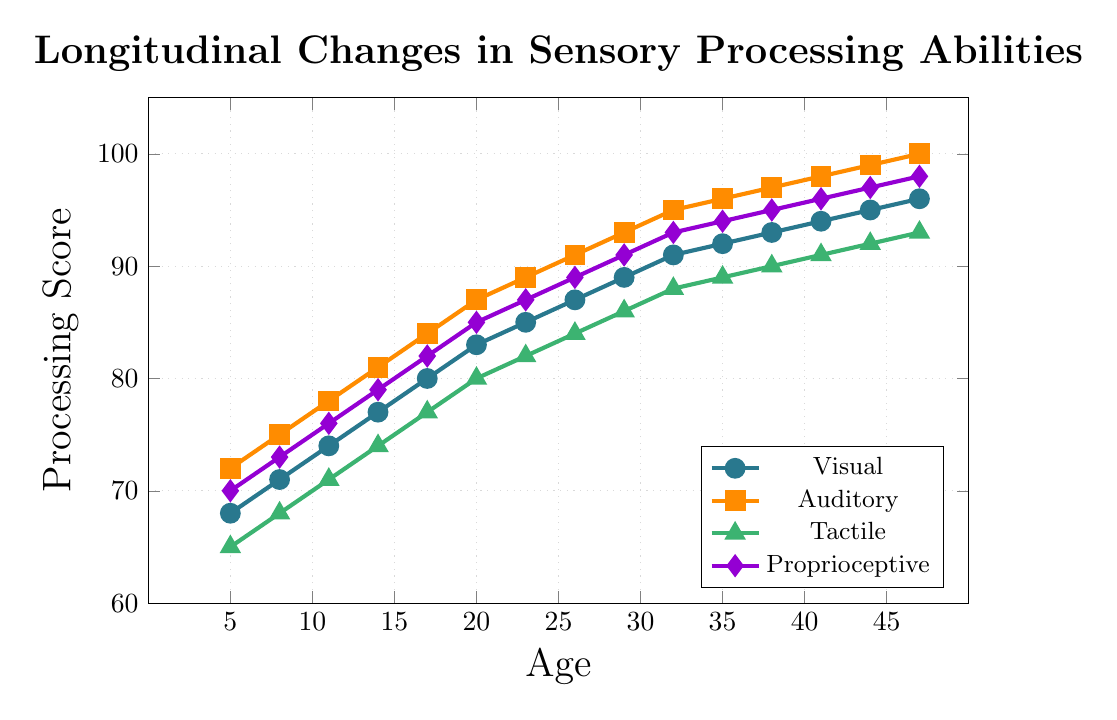What is the overall trend in the Visual Processing Score from age 5 to 47? The Visual Processing Score shows a consistent upward trend from age 5 to 47. This can be seen by the steady increase of the line representing Visual Processing in the chart.
Answer: Upward Trend Which sensory processing ability has the highest score at age 20? At age 20, Auditory Processing has the highest score among all sensory processing abilities. This can be observed by comparing the heights of the lines at the 20-year mark, where the Auditory line reaches the highest position.
Answer: Auditory Processing How many points did the Proprioceptive Processing Score increase from age 5 to age 20? To find the increase, subtract the Proprioceptive Processing Score at age 5 from the score at age 20. The Proprioceptive score at age 5 is 70 and at age 20 is 85. So, 85 - 70 = 15.
Answer: 15 Compare the growth rate of Tactile Processing and Auditory Processing between ages 5 and 17. Which one grew faster? Calculate the differences for both scores between ages 5 and 17. For Tactile Processing: 77 - 65 = 12. For Auditory Processing: 84 - 72 = 12. Both have the same increase, so they grew at the same rate during this period.
Answer: Same rate What is the average Visual Processing Score from age 5 to age 17? Add the Visual Processing Scores at ages 5, 8, 11, 14, and 17, and then divide by the number of data points. (68 + 71 + 74 + 77 + 80) / 5 = 370 / 5
Answer: 74 Between ages 11 and 23, which score increased the least? Calculate the difference for each score between ages 11 and 23. Visual: 85 - 74 = 11, Auditory: 89 - 78 = 11, Tactile: 82 - 71 = 11, Proprioceptive: 87 - 76 = 11. All scores increased by the same amount, so none increased the least.
Answer: None, all the same What is the final difference in the Tactile Processing Score from age 38 to age 47? Subtract the Tactile Processing Score at age 38 from the score at age 47. The Tactile score at age 38 is 90 and at age 47 is 93. So, 93 - 90 = 3.
Answer: 3 Between ages 14 and 32, which processing ability showed the highest overall increase in score? Calculate the differences for all scores between ages 14 and 32. Visual: 91 - 77 = 14, Auditory: 95 - 81 = 14, Tactile: 88 - 74 = 14, Proprioceptive: 93 - 79 = 14. The differences are the same, so all abilities showed the highest equal increase.
Answer: All the same Is there any age where all sensory processing abilities have the same score? Check the lines at different ages for any overlap in their values. None of the ages show the same value for all scores, as the lines never intersect at a single point.
Answer: No What are the coordinates of the data point for Auditory Processing at the age of 23? Based on the data, the Auditory Processing Score at age 23 is provided. Hence the coordinates for Auditory Processing at age 23 is (23, 89).
Answer: (23, 89) 